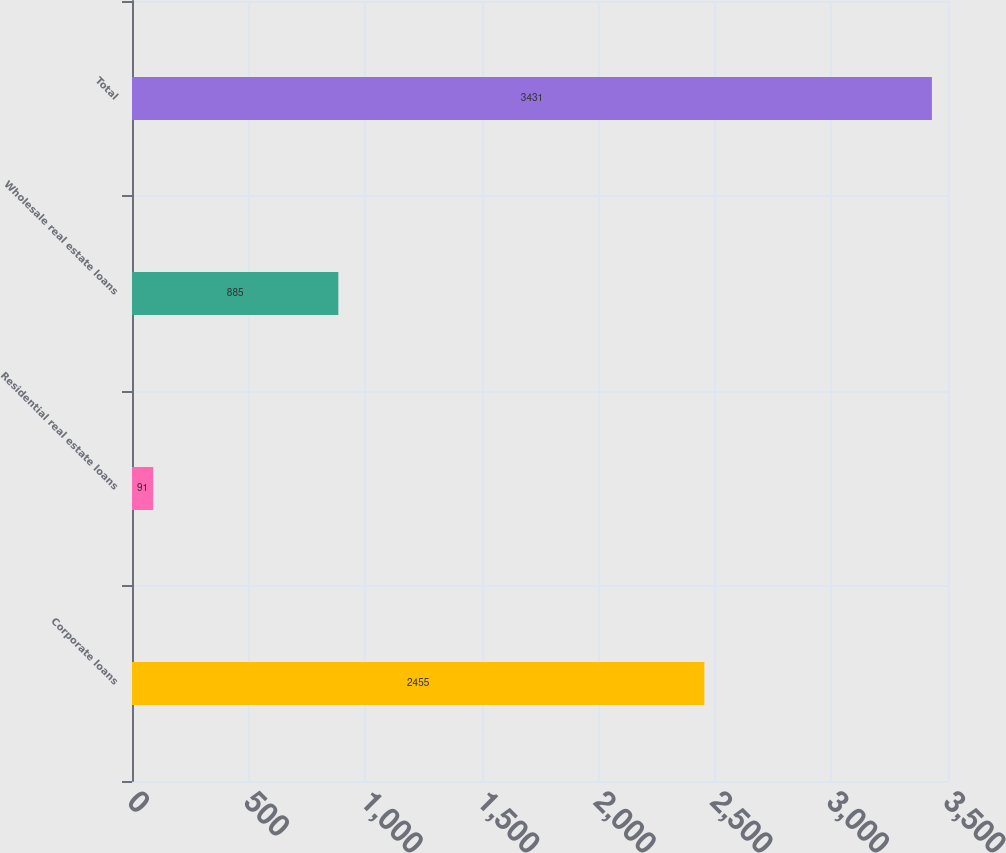Convert chart to OTSL. <chart><loc_0><loc_0><loc_500><loc_500><bar_chart><fcel>Corporate loans<fcel>Residential real estate loans<fcel>Wholesale real estate loans<fcel>Total<nl><fcel>2455<fcel>91<fcel>885<fcel>3431<nl></chart> 